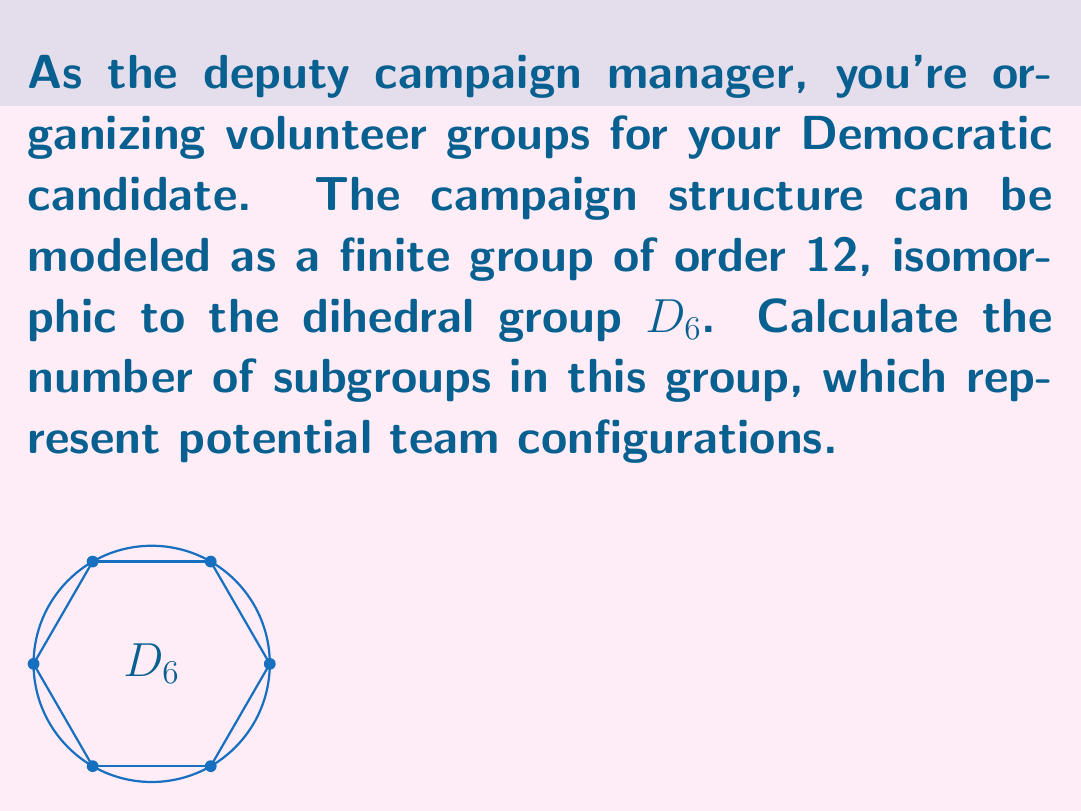Teach me how to tackle this problem. To find the number of subgroups in $D_6$, we follow these steps:

1) First, recall the structure of $D_6$:
   - It has order 12
   - It has 6 rotations (including identity) and 6 reflections

2) Subgroups of $D_6$ include:
   a) The trivial subgroup $\{e\}$ (order 1)
   b) The cyclic subgroup of order 6, $\langle r \rangle$ (1 subgroup)
   c) Three cyclic subgroups of order 2 generated by reflections (3 subgroups)
   d) Three cyclic subgroups of order 2 generated by 180° rotations (3 subgroups)
   e) Three dihedral subgroups of order 4, $D_2$ (3 subgroups)
   f) The full group $D_6$ itself (order 12)

3) Counting these subgroups:
   1 + 1 + 3 + 3 + 3 + 1 = 12

Therefore, $D_6$ has 12 subgroups in total, representing various possible team structures in the campaign organization.
Answer: 12 subgroups 